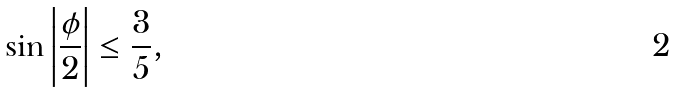Convert formula to latex. <formula><loc_0><loc_0><loc_500><loc_500>\sin { \left | \frac { \phi } { 2 } \right | } \leq \frac { 3 } { 5 } ,</formula> 